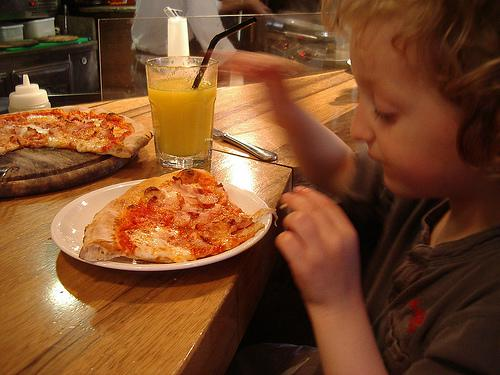Question: what is the child eating?
Choices:
A. Hotdog.
B. Cookies.
C. Pizza.
D. Hamburger.
Answer with the letter. Answer: C Question: how many pieces of pizza is on the child's plate?
Choices:
A. 1.
B. 6.
C. 2.
D. 8.
Answer with the letter. Answer: A Question: what is the child using to eat?
Choices:
A. Fork.
B. Spoon.
C. Fingers.
D. Hands.
Answer with the letter. Answer: D 